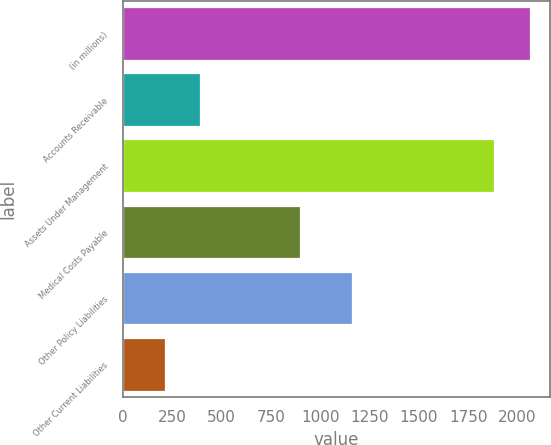<chart> <loc_0><loc_0><loc_500><loc_500><bar_chart><fcel>(in millions)<fcel>Accounts Receivable<fcel>Assets Under Management<fcel>Medical Costs Payable<fcel>Other Policy Liabilities<fcel>Other Current Liabilities<nl><fcel>2062.3<fcel>390.3<fcel>1883<fcel>899<fcel>1162<fcel>211<nl></chart> 